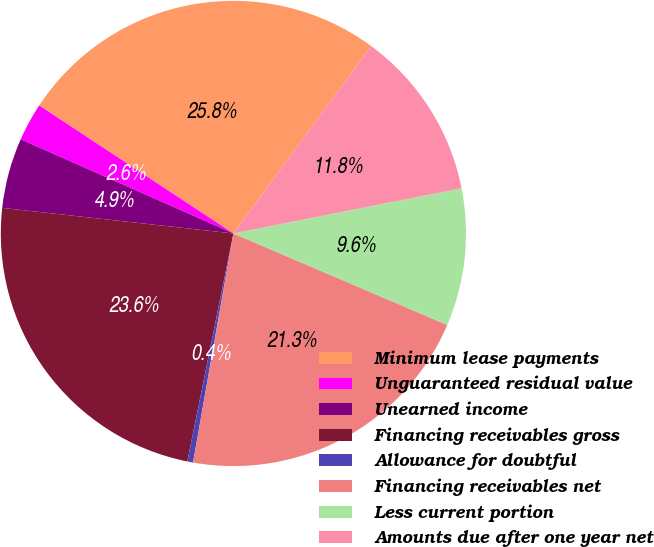Convert chart to OTSL. <chart><loc_0><loc_0><loc_500><loc_500><pie_chart><fcel>Minimum lease payments<fcel>Unguaranteed residual value<fcel>Unearned income<fcel>Financing receivables gross<fcel>Allowance for doubtful<fcel>Financing receivables net<fcel>Less current portion<fcel>Amounts due after one year net<nl><fcel>25.82%<fcel>2.64%<fcel>4.88%<fcel>23.58%<fcel>0.4%<fcel>21.34%<fcel>9.55%<fcel>11.79%<nl></chart> 